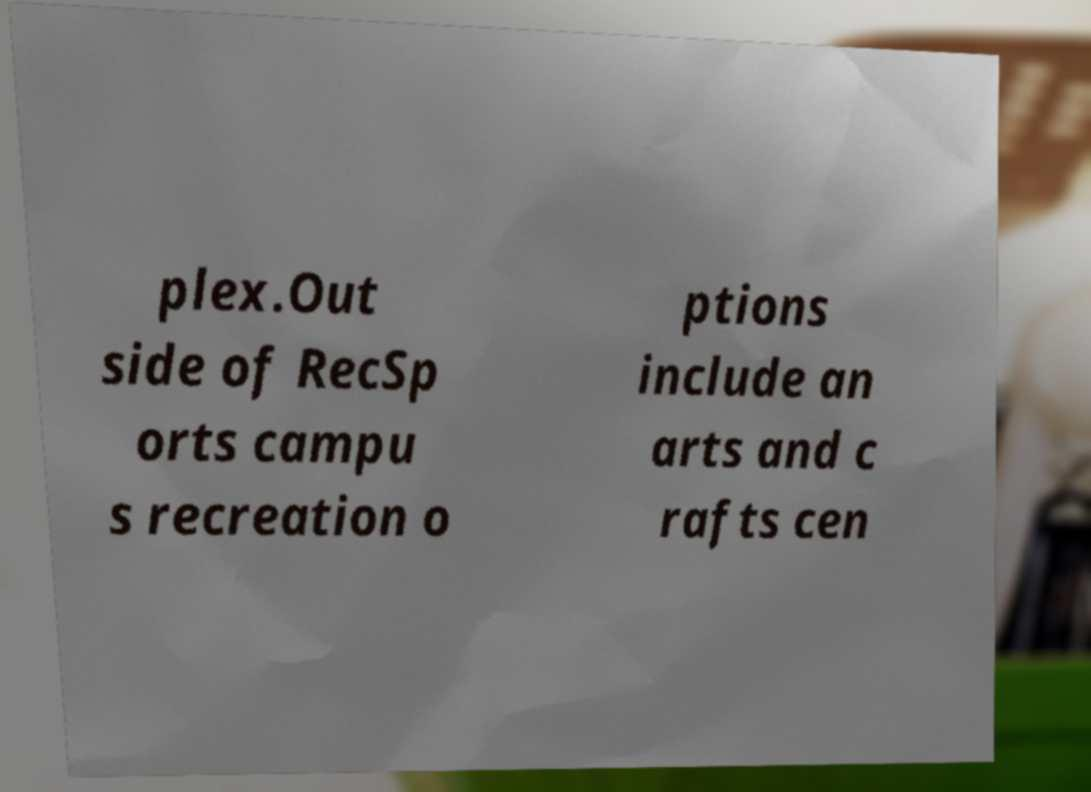Can you read and provide the text displayed in the image?This photo seems to have some interesting text. Can you extract and type it out for me? plex.Out side of RecSp orts campu s recreation o ptions include an arts and c rafts cen 